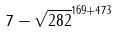Convert formula to latex. <formula><loc_0><loc_0><loc_500><loc_500>7 - \sqrt { 2 8 2 } ^ { 1 6 9 + 4 7 3 }</formula> 